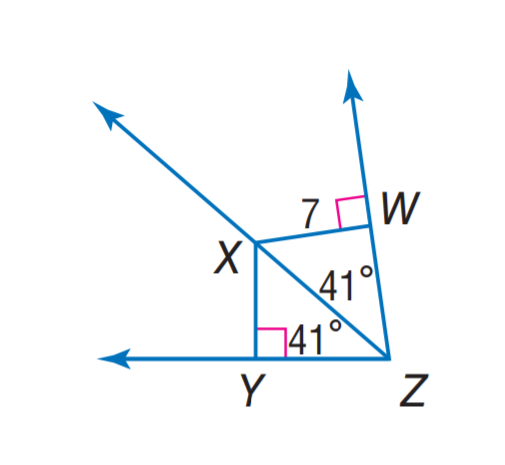Question: Find X Y.
Choices:
A. 3.5
B. 7
C. 34
D. 41
Answer with the letter. Answer: B 